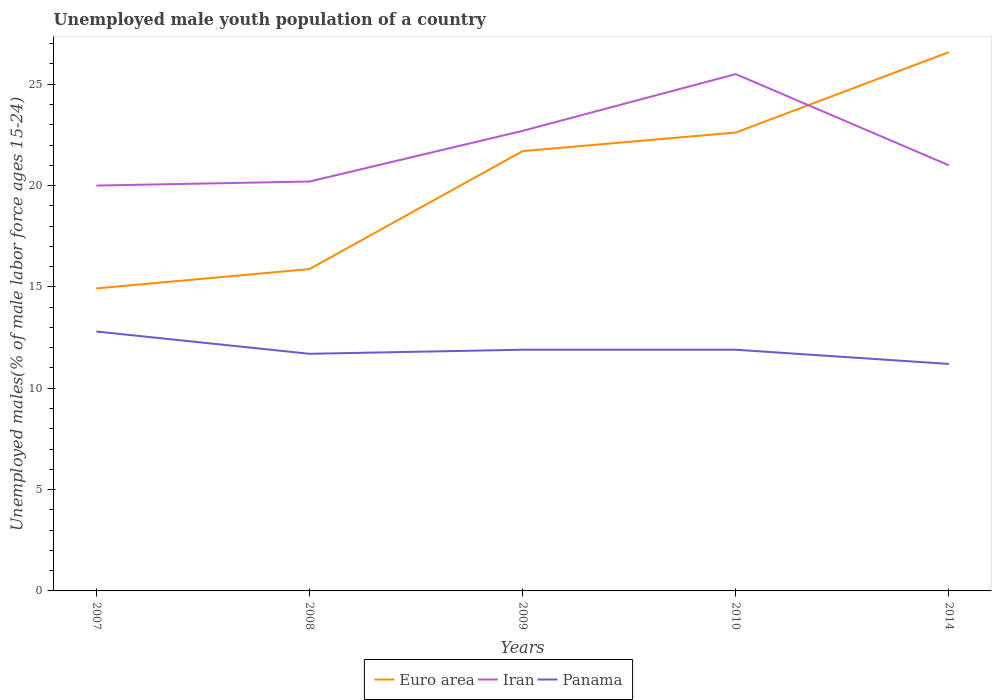How many different coloured lines are there?
Offer a very short reply. 3. Is the number of lines equal to the number of legend labels?
Your answer should be very brief. Yes. Across all years, what is the maximum percentage of unemployed male youth population in Panama?
Your answer should be compact. 11.2. What is the total percentage of unemployed male youth population in Euro area in the graph?
Your response must be concise. -10.7. What is the difference between the highest and the second highest percentage of unemployed male youth population in Panama?
Make the answer very short. 1.6. What is the difference between the highest and the lowest percentage of unemployed male youth population in Panama?
Offer a very short reply. 1. How many lines are there?
Your answer should be very brief. 3. What is the difference between two consecutive major ticks on the Y-axis?
Your answer should be compact. 5. Are the values on the major ticks of Y-axis written in scientific E-notation?
Ensure brevity in your answer.  No. Does the graph contain grids?
Your response must be concise. No. Where does the legend appear in the graph?
Give a very brief answer. Bottom center. How are the legend labels stacked?
Make the answer very short. Horizontal. What is the title of the graph?
Your response must be concise. Unemployed male youth population of a country. Does "Latin America(all income levels)" appear as one of the legend labels in the graph?
Your answer should be compact. No. What is the label or title of the Y-axis?
Ensure brevity in your answer.  Unemployed males(% of male labor force ages 15-24). What is the Unemployed males(% of male labor force ages 15-24) in Euro area in 2007?
Ensure brevity in your answer.  14.93. What is the Unemployed males(% of male labor force ages 15-24) of Panama in 2007?
Offer a terse response. 12.8. What is the Unemployed males(% of male labor force ages 15-24) of Euro area in 2008?
Your answer should be very brief. 15.88. What is the Unemployed males(% of male labor force ages 15-24) of Iran in 2008?
Keep it short and to the point. 20.2. What is the Unemployed males(% of male labor force ages 15-24) of Panama in 2008?
Offer a very short reply. 11.7. What is the Unemployed males(% of male labor force ages 15-24) in Euro area in 2009?
Offer a terse response. 21.7. What is the Unemployed males(% of male labor force ages 15-24) of Iran in 2009?
Provide a succinct answer. 22.7. What is the Unemployed males(% of male labor force ages 15-24) in Panama in 2009?
Offer a terse response. 11.9. What is the Unemployed males(% of male labor force ages 15-24) of Euro area in 2010?
Keep it short and to the point. 22.62. What is the Unemployed males(% of male labor force ages 15-24) in Panama in 2010?
Provide a succinct answer. 11.9. What is the Unemployed males(% of male labor force ages 15-24) of Euro area in 2014?
Keep it short and to the point. 26.58. What is the Unemployed males(% of male labor force ages 15-24) of Iran in 2014?
Offer a very short reply. 21. What is the Unemployed males(% of male labor force ages 15-24) of Panama in 2014?
Make the answer very short. 11.2. Across all years, what is the maximum Unemployed males(% of male labor force ages 15-24) of Euro area?
Make the answer very short. 26.58. Across all years, what is the maximum Unemployed males(% of male labor force ages 15-24) of Panama?
Offer a very short reply. 12.8. Across all years, what is the minimum Unemployed males(% of male labor force ages 15-24) in Euro area?
Ensure brevity in your answer.  14.93. Across all years, what is the minimum Unemployed males(% of male labor force ages 15-24) in Panama?
Provide a succinct answer. 11.2. What is the total Unemployed males(% of male labor force ages 15-24) in Euro area in the graph?
Your answer should be very brief. 101.71. What is the total Unemployed males(% of male labor force ages 15-24) in Iran in the graph?
Provide a short and direct response. 109.4. What is the total Unemployed males(% of male labor force ages 15-24) of Panama in the graph?
Your answer should be very brief. 59.5. What is the difference between the Unemployed males(% of male labor force ages 15-24) of Euro area in 2007 and that in 2008?
Offer a terse response. -0.95. What is the difference between the Unemployed males(% of male labor force ages 15-24) of Iran in 2007 and that in 2008?
Provide a succinct answer. -0.2. What is the difference between the Unemployed males(% of male labor force ages 15-24) of Euro area in 2007 and that in 2009?
Your response must be concise. -6.77. What is the difference between the Unemployed males(% of male labor force ages 15-24) of Panama in 2007 and that in 2009?
Offer a very short reply. 0.9. What is the difference between the Unemployed males(% of male labor force ages 15-24) in Euro area in 2007 and that in 2010?
Give a very brief answer. -7.69. What is the difference between the Unemployed males(% of male labor force ages 15-24) in Iran in 2007 and that in 2010?
Give a very brief answer. -5.5. What is the difference between the Unemployed males(% of male labor force ages 15-24) in Euro area in 2007 and that in 2014?
Your answer should be very brief. -11.66. What is the difference between the Unemployed males(% of male labor force ages 15-24) of Euro area in 2008 and that in 2009?
Offer a terse response. -5.82. What is the difference between the Unemployed males(% of male labor force ages 15-24) of Panama in 2008 and that in 2009?
Your answer should be very brief. -0.2. What is the difference between the Unemployed males(% of male labor force ages 15-24) in Euro area in 2008 and that in 2010?
Offer a very short reply. -6.74. What is the difference between the Unemployed males(% of male labor force ages 15-24) in Iran in 2008 and that in 2010?
Your response must be concise. -5.3. What is the difference between the Unemployed males(% of male labor force ages 15-24) in Panama in 2008 and that in 2010?
Keep it short and to the point. -0.2. What is the difference between the Unemployed males(% of male labor force ages 15-24) of Euro area in 2008 and that in 2014?
Give a very brief answer. -10.7. What is the difference between the Unemployed males(% of male labor force ages 15-24) of Euro area in 2009 and that in 2010?
Your response must be concise. -0.92. What is the difference between the Unemployed males(% of male labor force ages 15-24) in Iran in 2009 and that in 2010?
Make the answer very short. -2.8. What is the difference between the Unemployed males(% of male labor force ages 15-24) in Euro area in 2009 and that in 2014?
Your answer should be compact. -4.88. What is the difference between the Unemployed males(% of male labor force ages 15-24) of Iran in 2009 and that in 2014?
Keep it short and to the point. 1.7. What is the difference between the Unemployed males(% of male labor force ages 15-24) in Panama in 2009 and that in 2014?
Provide a short and direct response. 0.7. What is the difference between the Unemployed males(% of male labor force ages 15-24) in Euro area in 2010 and that in 2014?
Your answer should be very brief. -3.96. What is the difference between the Unemployed males(% of male labor force ages 15-24) in Iran in 2010 and that in 2014?
Your response must be concise. 4.5. What is the difference between the Unemployed males(% of male labor force ages 15-24) in Euro area in 2007 and the Unemployed males(% of male labor force ages 15-24) in Iran in 2008?
Your answer should be compact. -5.27. What is the difference between the Unemployed males(% of male labor force ages 15-24) of Euro area in 2007 and the Unemployed males(% of male labor force ages 15-24) of Panama in 2008?
Ensure brevity in your answer.  3.23. What is the difference between the Unemployed males(% of male labor force ages 15-24) in Euro area in 2007 and the Unemployed males(% of male labor force ages 15-24) in Iran in 2009?
Give a very brief answer. -7.77. What is the difference between the Unemployed males(% of male labor force ages 15-24) in Euro area in 2007 and the Unemployed males(% of male labor force ages 15-24) in Panama in 2009?
Provide a short and direct response. 3.03. What is the difference between the Unemployed males(% of male labor force ages 15-24) in Iran in 2007 and the Unemployed males(% of male labor force ages 15-24) in Panama in 2009?
Make the answer very short. 8.1. What is the difference between the Unemployed males(% of male labor force ages 15-24) of Euro area in 2007 and the Unemployed males(% of male labor force ages 15-24) of Iran in 2010?
Provide a succinct answer. -10.57. What is the difference between the Unemployed males(% of male labor force ages 15-24) in Euro area in 2007 and the Unemployed males(% of male labor force ages 15-24) in Panama in 2010?
Provide a short and direct response. 3.03. What is the difference between the Unemployed males(% of male labor force ages 15-24) in Euro area in 2007 and the Unemployed males(% of male labor force ages 15-24) in Iran in 2014?
Your answer should be very brief. -6.07. What is the difference between the Unemployed males(% of male labor force ages 15-24) of Euro area in 2007 and the Unemployed males(% of male labor force ages 15-24) of Panama in 2014?
Offer a very short reply. 3.73. What is the difference between the Unemployed males(% of male labor force ages 15-24) of Iran in 2007 and the Unemployed males(% of male labor force ages 15-24) of Panama in 2014?
Your response must be concise. 8.8. What is the difference between the Unemployed males(% of male labor force ages 15-24) of Euro area in 2008 and the Unemployed males(% of male labor force ages 15-24) of Iran in 2009?
Give a very brief answer. -6.82. What is the difference between the Unemployed males(% of male labor force ages 15-24) of Euro area in 2008 and the Unemployed males(% of male labor force ages 15-24) of Panama in 2009?
Your answer should be compact. 3.98. What is the difference between the Unemployed males(% of male labor force ages 15-24) in Euro area in 2008 and the Unemployed males(% of male labor force ages 15-24) in Iran in 2010?
Ensure brevity in your answer.  -9.62. What is the difference between the Unemployed males(% of male labor force ages 15-24) of Euro area in 2008 and the Unemployed males(% of male labor force ages 15-24) of Panama in 2010?
Your answer should be very brief. 3.98. What is the difference between the Unemployed males(% of male labor force ages 15-24) of Iran in 2008 and the Unemployed males(% of male labor force ages 15-24) of Panama in 2010?
Give a very brief answer. 8.3. What is the difference between the Unemployed males(% of male labor force ages 15-24) in Euro area in 2008 and the Unemployed males(% of male labor force ages 15-24) in Iran in 2014?
Provide a short and direct response. -5.12. What is the difference between the Unemployed males(% of male labor force ages 15-24) in Euro area in 2008 and the Unemployed males(% of male labor force ages 15-24) in Panama in 2014?
Make the answer very short. 4.68. What is the difference between the Unemployed males(% of male labor force ages 15-24) of Iran in 2008 and the Unemployed males(% of male labor force ages 15-24) of Panama in 2014?
Your answer should be compact. 9. What is the difference between the Unemployed males(% of male labor force ages 15-24) of Euro area in 2009 and the Unemployed males(% of male labor force ages 15-24) of Iran in 2010?
Your answer should be very brief. -3.8. What is the difference between the Unemployed males(% of male labor force ages 15-24) of Euro area in 2009 and the Unemployed males(% of male labor force ages 15-24) of Panama in 2010?
Ensure brevity in your answer.  9.8. What is the difference between the Unemployed males(% of male labor force ages 15-24) in Iran in 2009 and the Unemployed males(% of male labor force ages 15-24) in Panama in 2010?
Your answer should be compact. 10.8. What is the difference between the Unemployed males(% of male labor force ages 15-24) in Euro area in 2009 and the Unemployed males(% of male labor force ages 15-24) in Iran in 2014?
Offer a very short reply. 0.7. What is the difference between the Unemployed males(% of male labor force ages 15-24) of Euro area in 2009 and the Unemployed males(% of male labor force ages 15-24) of Panama in 2014?
Ensure brevity in your answer.  10.5. What is the difference between the Unemployed males(% of male labor force ages 15-24) of Iran in 2009 and the Unemployed males(% of male labor force ages 15-24) of Panama in 2014?
Your response must be concise. 11.5. What is the difference between the Unemployed males(% of male labor force ages 15-24) in Euro area in 2010 and the Unemployed males(% of male labor force ages 15-24) in Iran in 2014?
Offer a terse response. 1.62. What is the difference between the Unemployed males(% of male labor force ages 15-24) in Euro area in 2010 and the Unemployed males(% of male labor force ages 15-24) in Panama in 2014?
Your answer should be very brief. 11.42. What is the average Unemployed males(% of male labor force ages 15-24) in Euro area per year?
Provide a short and direct response. 20.34. What is the average Unemployed males(% of male labor force ages 15-24) of Iran per year?
Give a very brief answer. 21.88. What is the average Unemployed males(% of male labor force ages 15-24) in Panama per year?
Your answer should be very brief. 11.9. In the year 2007, what is the difference between the Unemployed males(% of male labor force ages 15-24) of Euro area and Unemployed males(% of male labor force ages 15-24) of Iran?
Make the answer very short. -5.07. In the year 2007, what is the difference between the Unemployed males(% of male labor force ages 15-24) of Euro area and Unemployed males(% of male labor force ages 15-24) of Panama?
Provide a succinct answer. 2.13. In the year 2007, what is the difference between the Unemployed males(% of male labor force ages 15-24) in Iran and Unemployed males(% of male labor force ages 15-24) in Panama?
Your answer should be very brief. 7.2. In the year 2008, what is the difference between the Unemployed males(% of male labor force ages 15-24) of Euro area and Unemployed males(% of male labor force ages 15-24) of Iran?
Offer a very short reply. -4.32. In the year 2008, what is the difference between the Unemployed males(% of male labor force ages 15-24) of Euro area and Unemployed males(% of male labor force ages 15-24) of Panama?
Offer a very short reply. 4.18. In the year 2009, what is the difference between the Unemployed males(% of male labor force ages 15-24) of Euro area and Unemployed males(% of male labor force ages 15-24) of Iran?
Your answer should be very brief. -1. In the year 2009, what is the difference between the Unemployed males(% of male labor force ages 15-24) in Euro area and Unemployed males(% of male labor force ages 15-24) in Panama?
Give a very brief answer. 9.8. In the year 2010, what is the difference between the Unemployed males(% of male labor force ages 15-24) in Euro area and Unemployed males(% of male labor force ages 15-24) in Iran?
Provide a succinct answer. -2.88. In the year 2010, what is the difference between the Unemployed males(% of male labor force ages 15-24) in Euro area and Unemployed males(% of male labor force ages 15-24) in Panama?
Keep it short and to the point. 10.72. In the year 2010, what is the difference between the Unemployed males(% of male labor force ages 15-24) in Iran and Unemployed males(% of male labor force ages 15-24) in Panama?
Your response must be concise. 13.6. In the year 2014, what is the difference between the Unemployed males(% of male labor force ages 15-24) of Euro area and Unemployed males(% of male labor force ages 15-24) of Iran?
Your answer should be compact. 5.58. In the year 2014, what is the difference between the Unemployed males(% of male labor force ages 15-24) in Euro area and Unemployed males(% of male labor force ages 15-24) in Panama?
Provide a short and direct response. 15.38. What is the ratio of the Unemployed males(% of male labor force ages 15-24) in Panama in 2007 to that in 2008?
Make the answer very short. 1.09. What is the ratio of the Unemployed males(% of male labor force ages 15-24) of Euro area in 2007 to that in 2009?
Your answer should be very brief. 0.69. What is the ratio of the Unemployed males(% of male labor force ages 15-24) of Iran in 2007 to that in 2009?
Provide a succinct answer. 0.88. What is the ratio of the Unemployed males(% of male labor force ages 15-24) in Panama in 2007 to that in 2009?
Provide a succinct answer. 1.08. What is the ratio of the Unemployed males(% of male labor force ages 15-24) in Euro area in 2007 to that in 2010?
Make the answer very short. 0.66. What is the ratio of the Unemployed males(% of male labor force ages 15-24) of Iran in 2007 to that in 2010?
Make the answer very short. 0.78. What is the ratio of the Unemployed males(% of male labor force ages 15-24) in Panama in 2007 to that in 2010?
Your answer should be compact. 1.08. What is the ratio of the Unemployed males(% of male labor force ages 15-24) in Euro area in 2007 to that in 2014?
Offer a terse response. 0.56. What is the ratio of the Unemployed males(% of male labor force ages 15-24) of Euro area in 2008 to that in 2009?
Provide a short and direct response. 0.73. What is the ratio of the Unemployed males(% of male labor force ages 15-24) in Iran in 2008 to that in 2009?
Offer a terse response. 0.89. What is the ratio of the Unemployed males(% of male labor force ages 15-24) in Panama in 2008 to that in 2009?
Provide a succinct answer. 0.98. What is the ratio of the Unemployed males(% of male labor force ages 15-24) of Euro area in 2008 to that in 2010?
Ensure brevity in your answer.  0.7. What is the ratio of the Unemployed males(% of male labor force ages 15-24) in Iran in 2008 to that in 2010?
Keep it short and to the point. 0.79. What is the ratio of the Unemployed males(% of male labor force ages 15-24) of Panama in 2008 to that in 2010?
Your response must be concise. 0.98. What is the ratio of the Unemployed males(% of male labor force ages 15-24) in Euro area in 2008 to that in 2014?
Keep it short and to the point. 0.6. What is the ratio of the Unemployed males(% of male labor force ages 15-24) in Iran in 2008 to that in 2014?
Your response must be concise. 0.96. What is the ratio of the Unemployed males(% of male labor force ages 15-24) in Panama in 2008 to that in 2014?
Ensure brevity in your answer.  1.04. What is the ratio of the Unemployed males(% of male labor force ages 15-24) of Euro area in 2009 to that in 2010?
Ensure brevity in your answer.  0.96. What is the ratio of the Unemployed males(% of male labor force ages 15-24) in Iran in 2009 to that in 2010?
Your response must be concise. 0.89. What is the ratio of the Unemployed males(% of male labor force ages 15-24) in Euro area in 2009 to that in 2014?
Your response must be concise. 0.82. What is the ratio of the Unemployed males(% of male labor force ages 15-24) of Iran in 2009 to that in 2014?
Your answer should be compact. 1.08. What is the ratio of the Unemployed males(% of male labor force ages 15-24) in Euro area in 2010 to that in 2014?
Provide a succinct answer. 0.85. What is the ratio of the Unemployed males(% of male labor force ages 15-24) in Iran in 2010 to that in 2014?
Provide a succinct answer. 1.21. What is the ratio of the Unemployed males(% of male labor force ages 15-24) in Panama in 2010 to that in 2014?
Offer a very short reply. 1.06. What is the difference between the highest and the second highest Unemployed males(% of male labor force ages 15-24) of Euro area?
Your answer should be very brief. 3.96. What is the difference between the highest and the lowest Unemployed males(% of male labor force ages 15-24) of Euro area?
Provide a succinct answer. 11.66. What is the difference between the highest and the lowest Unemployed males(% of male labor force ages 15-24) of Panama?
Offer a very short reply. 1.6. 